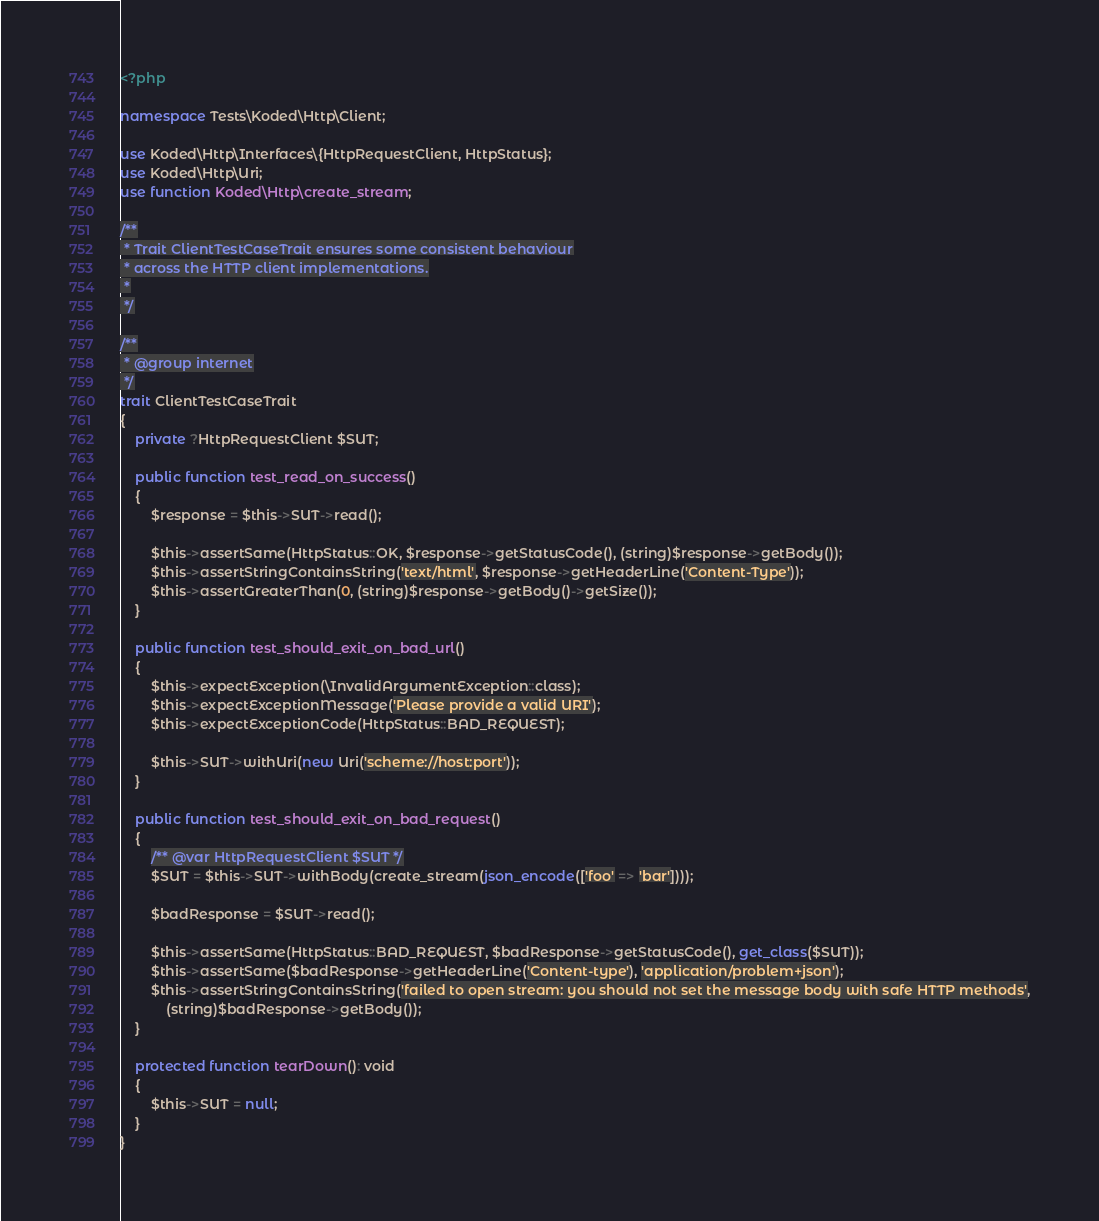Convert code to text. <code><loc_0><loc_0><loc_500><loc_500><_PHP_><?php

namespace Tests\Koded\Http\Client;

use Koded\Http\Interfaces\{HttpRequestClient, HttpStatus};
use Koded\Http\Uri;
use function Koded\Http\create_stream;

/**
 * Trait ClientTestCaseTrait ensures some consistent behaviour
 * across the HTTP client implementations.
 *
 */

/**
 * @group internet
 */
trait ClientTestCaseTrait
{
    private ?HttpRequestClient $SUT;

    public function test_read_on_success()
    {
        $response = $this->SUT->read();

        $this->assertSame(HttpStatus::OK, $response->getStatusCode(), (string)$response->getBody());
        $this->assertStringContainsString('text/html', $response->getHeaderLine('Content-Type'));
        $this->assertGreaterThan(0, (string)$response->getBody()->getSize());
    }

    public function test_should_exit_on_bad_url()
    {
        $this->expectException(\InvalidArgumentException::class);
        $this->expectExceptionMessage('Please provide a valid URI');
        $this->expectExceptionCode(HttpStatus::BAD_REQUEST);

        $this->SUT->withUri(new Uri('scheme://host:port'));
    }

    public function test_should_exit_on_bad_request()
    {
        /** @var HttpRequestClient $SUT */
        $SUT = $this->SUT->withBody(create_stream(json_encode(['foo' => 'bar'])));

        $badResponse = $SUT->read();

        $this->assertSame(HttpStatus::BAD_REQUEST, $badResponse->getStatusCode(), get_class($SUT));
        $this->assertSame($badResponse->getHeaderLine('Content-type'), 'application/problem+json');
        $this->assertStringContainsString('failed to open stream: you should not set the message body with safe HTTP methods',
            (string)$badResponse->getBody());
    }

    protected function tearDown(): void
    {
        $this->SUT = null;
    }
}
</code> 